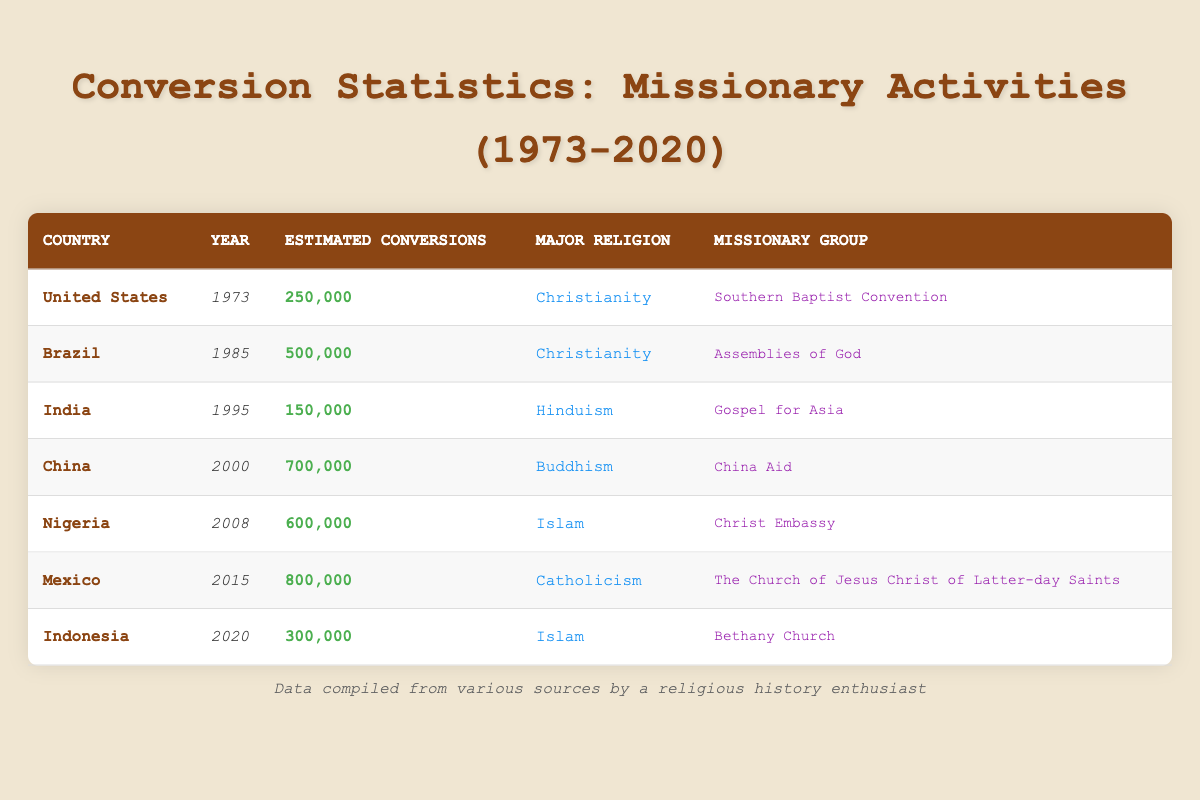What country had the highest estimated conversions in the year 2015? According to the table, Mexico had the highest estimated conversions with a total of 800,000 in the year 2015.
Answer: Mexico Which year did Nigeria have 600,000 estimated conversions? The table directly shows that Nigeria had 600,000 estimated conversions in the year 2008.
Answer: 2008 What is the total number of estimated conversions recorded for India and the United States? To find the total, add India's conversions (150,000) and the United States' conversions (250,000): 150,000 + 250,000 = 400,000.
Answer: 400,000 Is it true that the majority religion for conversions in 2000 was Buddhism? The table lists China as having the majority religion of Buddhism with 700,000 conversions in the year 2000, making the statement true.
Answer: Yes Which missionary group was responsible for the highest estimated conversions in the table? Mexico's conversions led by The Church of Jesus Christ of Latter-day Saints amounted to 800,000, the highest total in the table.
Answer: The Church of Jesus Christ of Latter-day Saints What is the difference in estimated conversions between Brazil in 1985 and China in 2000? Brazil had 500,000 conversions in 1985 and China had 700,000 in 2000. The difference is calculated by subtracting Brazil's conversions from China's: 700,000 - 500,000 = 200,000.
Answer: 200,000 In which year was the estimated number of conversions for Indonesia the lowest? The only entry for Indonesia is in 2020, with an estimated 300,000 conversions. Therefore, this is also the lowest recorded for the given years in the table.
Answer: 2020 What is the average estimated conversions per year from the years listed (1973, 1985, 1995, 2000, 2008, 2015, 2020)? The total estimated conversions from the table are: 250,000 + 500,000 + 150,000 + 700,000 + 600,000 + 800,000 + 300,000 = 3,250,000. There are 7 entries, so the average is calculated by 3,250,000 / 7 = 464,285.71, which we round down to 464,286 for simplicity.
Answer: 464,286 Which country had the lowest estimated conversions in the table? The lowest estimated conversions is 150,000 for India in 1995, as seen directly from the table.
Answer: India Did India have any conversions closer to 500,000 than the estimated conversions for Nigeria in 2008? India had 150,000 conversions, while Nigeria had 600,000. Since 150,000 is not closer to 500,000 than 600,000 is, the answer is no.
Answer: No 